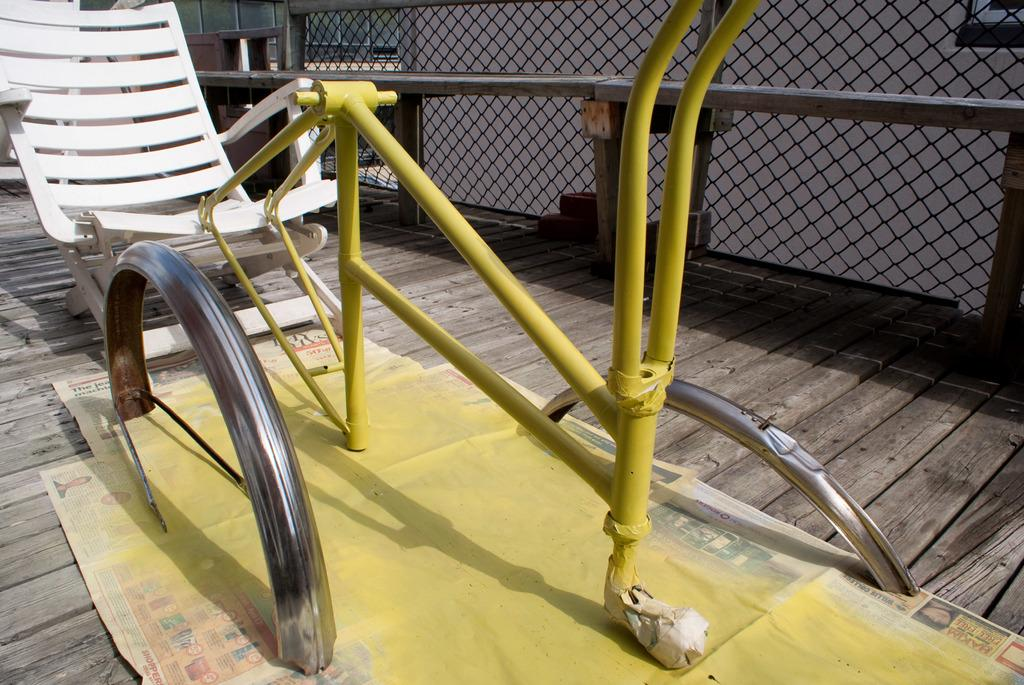What object is located on the left side of the image? There is a chair on the left side of the image. Where is the chair positioned in relation to the floor? The chair is on the floor. What can be seen in the background of the image? There is fencing and a building in the background of the image. How many grapes are hanging from the chair in the image? There are no grapes present in the image. What type of camera is being used to take the picture? The facts provided do not mention a camera being used to take the picture, so we cannot determine the type of camera used. 